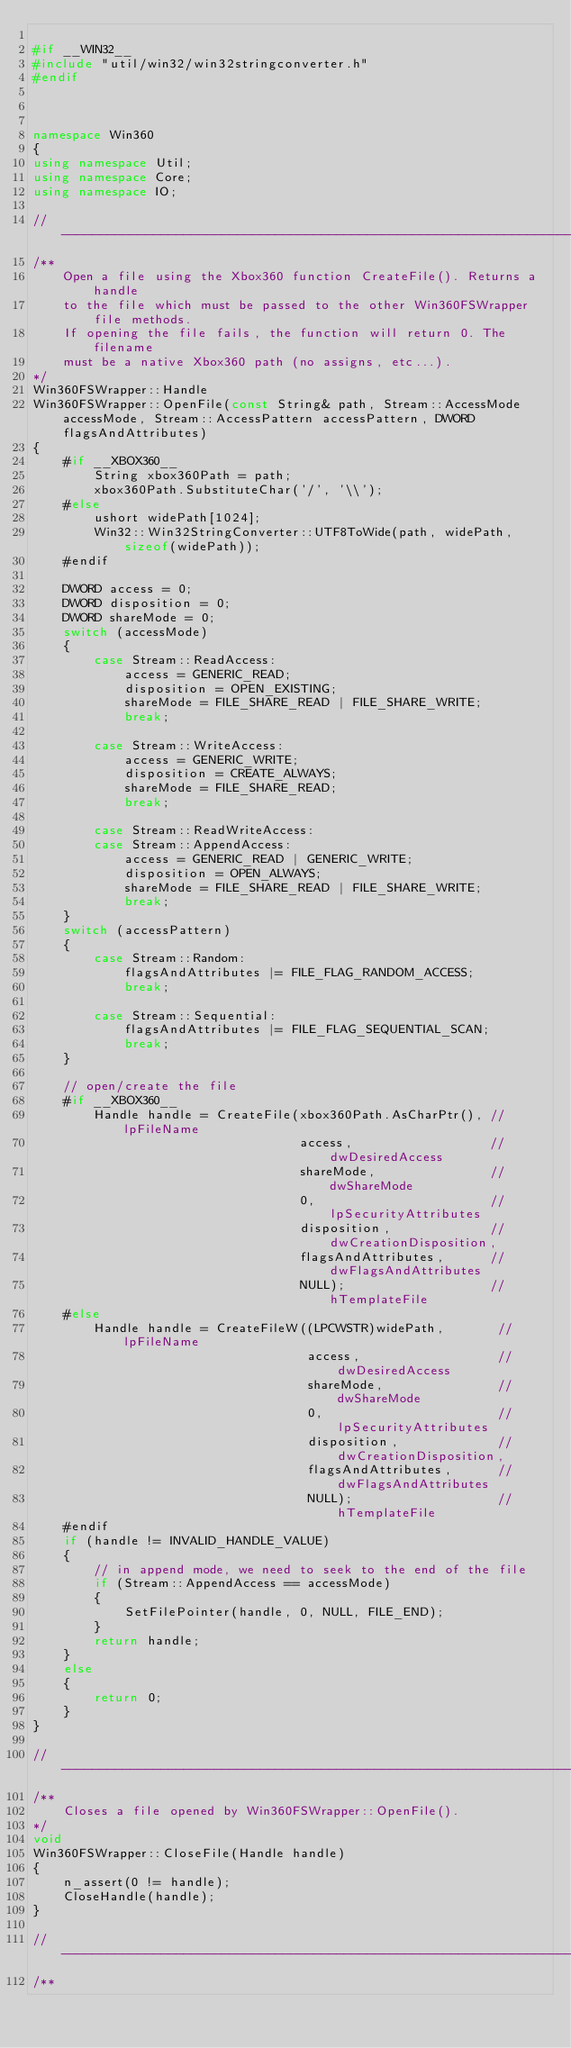Convert code to text. <code><loc_0><loc_0><loc_500><loc_500><_C++_>
#if __WIN32__
#include "util/win32/win32stringconverter.h"
#endif



namespace Win360
{
using namespace Util;
using namespace Core;
using namespace IO;

//------------------------------------------------------------------------------
/**
    Open a file using the Xbox360 function CreateFile(). Returns a handle
    to the file which must be passed to the other Win360FSWrapper file methods.
    If opening the file fails, the function will return 0. The filename
    must be a native Xbox360 path (no assigns, etc...).
*/
Win360FSWrapper::Handle
Win360FSWrapper::OpenFile(const String& path, Stream::AccessMode accessMode, Stream::AccessPattern accessPattern, DWORD flagsAndAttributes)
{
    #if __XBOX360__
        String xbox360Path = path;
        xbox360Path.SubstituteChar('/', '\\');
    #else
        ushort widePath[1024];
        Win32::Win32StringConverter::UTF8ToWide(path, widePath, sizeof(widePath));
    #endif

    DWORD access = 0;
    DWORD disposition = 0;
    DWORD shareMode = 0;
    switch (accessMode)
    {
        case Stream::ReadAccess:
            access = GENERIC_READ;            
            disposition = OPEN_EXISTING;
            shareMode = FILE_SHARE_READ | FILE_SHARE_WRITE;
            break;

        case Stream::WriteAccess:
            access = GENERIC_WRITE;
            disposition = CREATE_ALWAYS;
            shareMode = FILE_SHARE_READ;
            break;

        case Stream::ReadWriteAccess:
        case Stream::AppendAccess:
            access = GENERIC_READ | GENERIC_WRITE;
            disposition = OPEN_ALWAYS;
            shareMode = FILE_SHARE_READ | FILE_SHARE_WRITE;
            break;
    }
    switch (accessPattern)
    {
        case Stream::Random:
            flagsAndAttributes |= FILE_FLAG_RANDOM_ACCESS;
            break;

        case Stream::Sequential:
            flagsAndAttributes |= FILE_FLAG_SEQUENTIAL_SCAN;
            break;
    }

    // open/create the file
    #if __XBOX360__
        Handle handle = CreateFile(xbox360Path.AsCharPtr(), // lpFileName
                                   access,                  // dwDesiredAccess
                                   shareMode,               // dwShareMode
                                   0,                       // lpSecurityAttributes
                                   disposition,             // dwCreationDisposition,
                                   flagsAndAttributes,      // dwFlagsAndAttributes
                                   NULL);                   // hTemplateFile
    #else
        Handle handle = CreateFileW((LPCWSTR)widePath,       // lpFileName
                                    access,                  // dwDesiredAccess
                                    shareMode,               // dwShareMode
                                    0,                       // lpSecurityAttributes
                                    disposition,             // dwCreationDisposition,
                                    flagsAndAttributes,      // dwFlagsAndAttributes
                                    NULL);                   // hTemplateFile
    #endif
    if (handle != INVALID_HANDLE_VALUE)
    {
        // in append mode, we need to seek to the end of the file
        if (Stream::AppendAccess == accessMode)
        {
            SetFilePointer(handle, 0, NULL, FILE_END);
        }
        return handle;
    }
    else
    {
        return 0;
    }
}

//------------------------------------------------------------------------------
/**
    Closes a file opened by Win360FSWrapper::OpenFile().
*/
void
Win360FSWrapper::CloseFile(Handle handle)
{
    n_assert(0 != handle);
    CloseHandle(handle);
}

//------------------------------------------------------------------------------
/**</code> 